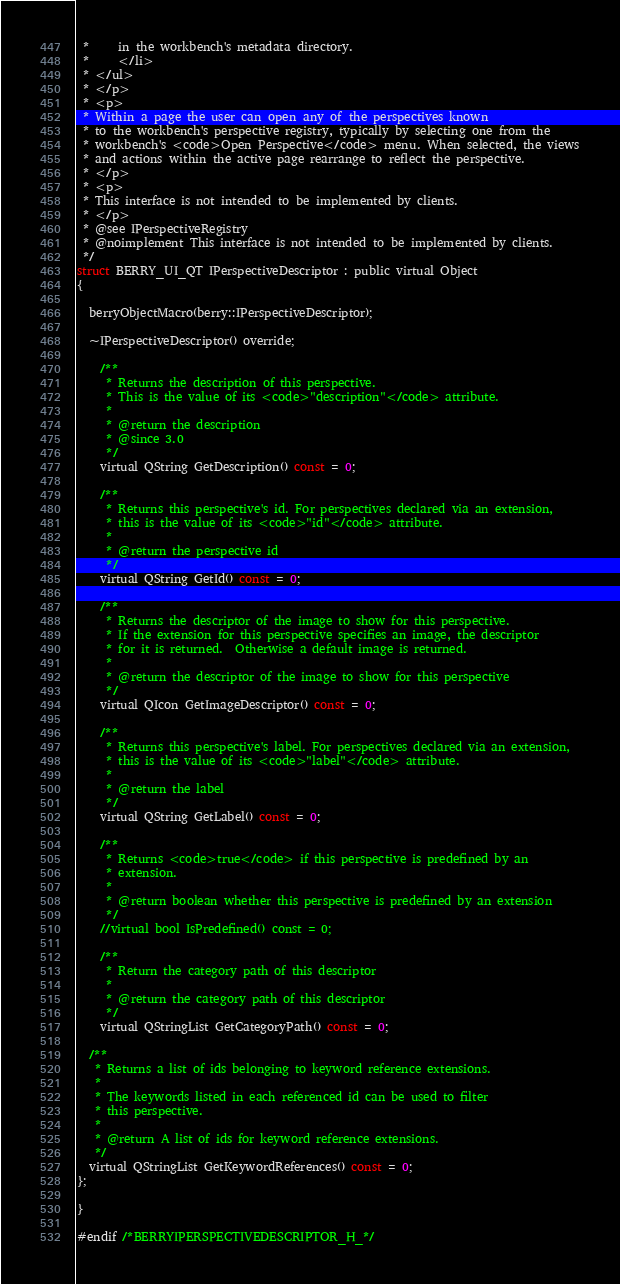Convert code to text. <code><loc_0><loc_0><loc_500><loc_500><_C_> *     in the workbench's metadata directory.
 *     </li>
 * </ul>
 * </p>
 * <p>
 * Within a page the user can open any of the perspectives known
 * to the workbench's perspective registry, typically by selecting one from the
 * workbench's <code>Open Perspective</code> menu. When selected, the views
 * and actions within the active page rearrange to reflect the perspective.
 * </p>
 * <p>
 * This interface is not intended to be implemented by clients.
 * </p>
 * @see IPerspectiveRegistry
 * @noimplement This interface is not intended to be implemented by clients.
 */
struct BERRY_UI_QT IPerspectiveDescriptor : public virtual Object
{

  berryObjectMacro(berry::IPerspectiveDescriptor);

  ~IPerspectiveDescriptor() override;

    /**
     * Returns the description of this perspective.
     * This is the value of its <code>"description"</code> attribute.
     *
     * @return the description
     * @since 3.0
     */
    virtual QString GetDescription() const = 0;

    /**
     * Returns this perspective's id. For perspectives declared via an extension,
     * this is the value of its <code>"id"</code> attribute.
     *
     * @return the perspective id
     */
    virtual QString GetId() const = 0;

    /**
     * Returns the descriptor of the image to show for this perspective.
     * If the extension for this perspective specifies an image, the descriptor
     * for it is returned.  Otherwise a default image is returned.
     *
     * @return the descriptor of the image to show for this perspective
     */
    virtual QIcon GetImageDescriptor() const = 0;

    /**
     * Returns this perspective's label. For perspectives declared via an extension,
     * this is the value of its <code>"label"</code> attribute.
     *
     * @return the label
     */
    virtual QString GetLabel() const = 0;

    /**
     * Returns <code>true</code> if this perspective is predefined by an
     * extension.
     *
     * @return boolean whether this perspective is predefined by an extension
     */
    //virtual bool IsPredefined() const = 0;

    /**
     * Return the category path of this descriptor
     *
     * @return the category path of this descriptor
     */
    virtual QStringList GetCategoryPath() const = 0;

  /**
   * Returns a list of ids belonging to keyword reference extensions.
   *
   * The keywords listed in each referenced id can be used to filter
   * this perspective.
   *
   * @return A list of ids for keyword reference extensions.
   */
  virtual QStringList GetKeywordReferences() const = 0;
};

}

#endif /*BERRYIPERSPECTIVEDESCRIPTOR_H_*/
</code> 